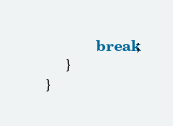<code> <loc_0><loc_0><loc_500><loc_500><_Java_>               break;
        }
   }

</code> 